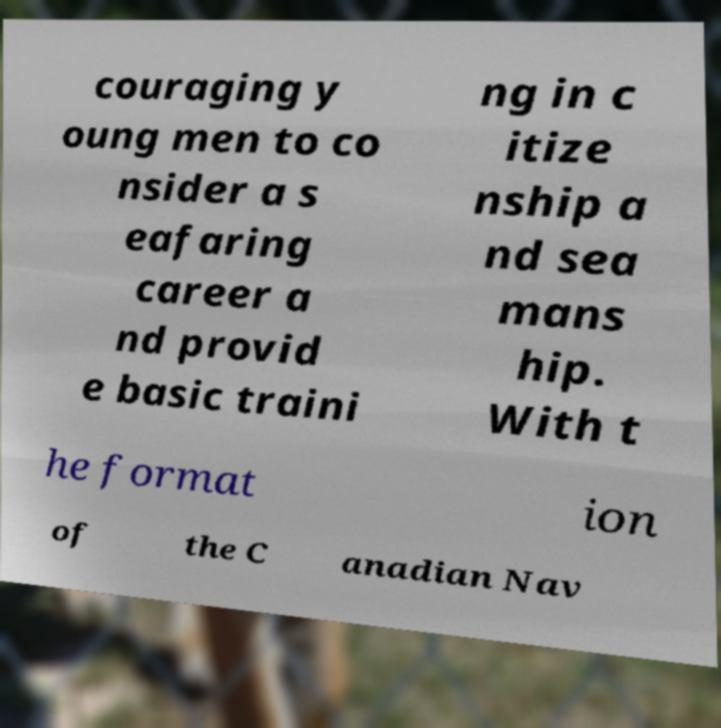There's text embedded in this image that I need extracted. Can you transcribe it verbatim? couraging y oung men to co nsider a s eafaring career a nd provid e basic traini ng in c itize nship a nd sea mans hip. With t he format ion of the C anadian Nav 